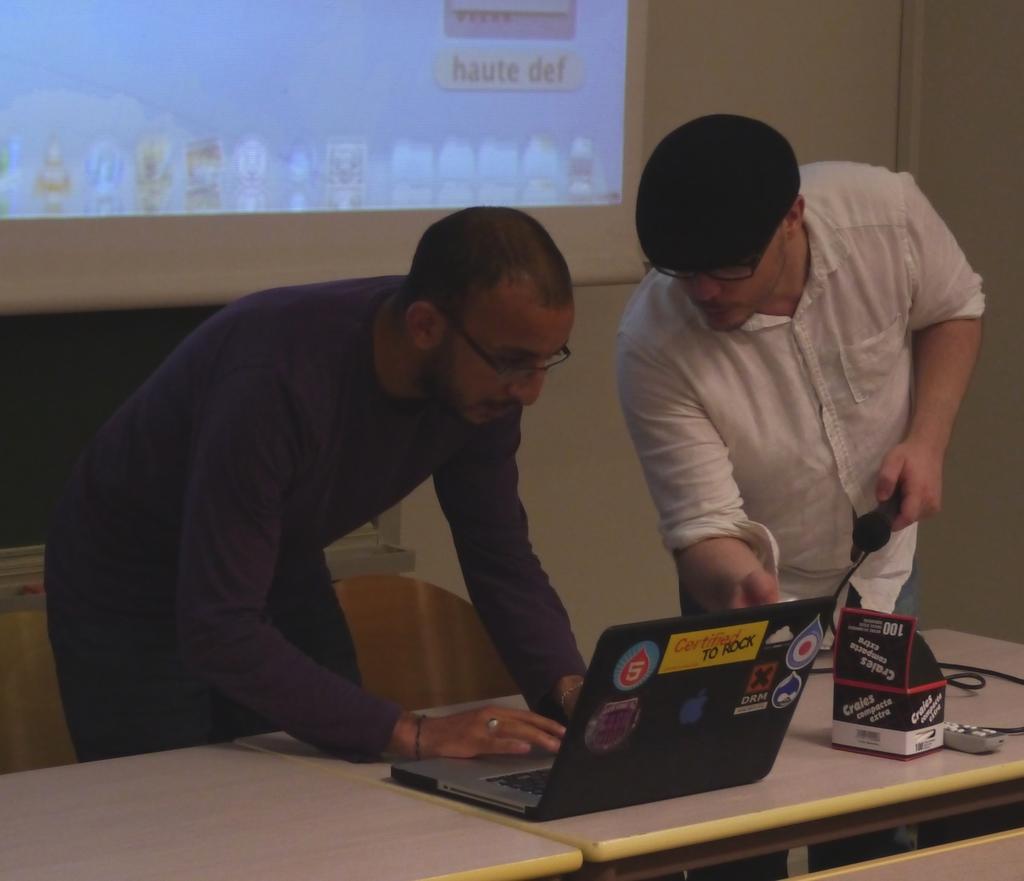In one or two sentences, can you explain what this image depicts? Two men are looking at a laptop on a table. 